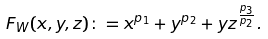<formula> <loc_0><loc_0><loc_500><loc_500>F _ { W } ( x , y , z ) \colon = x ^ { p _ { 1 } } + y ^ { p _ { 2 } } + y z ^ { \frac { p _ { 3 } } { p _ { 2 } } } .</formula> 